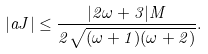Convert formula to latex. <formula><loc_0><loc_0><loc_500><loc_500>| a J | \leq \frac { | 2 \omega + 3 | M } { 2 \sqrt { ( \omega + 1 ) ( \omega + 2 ) } } .</formula> 